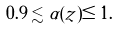Convert formula to latex. <formula><loc_0><loc_0><loc_500><loc_500>0 . 9 \lesssim \alpha ( z ) \leq 1 .</formula> 